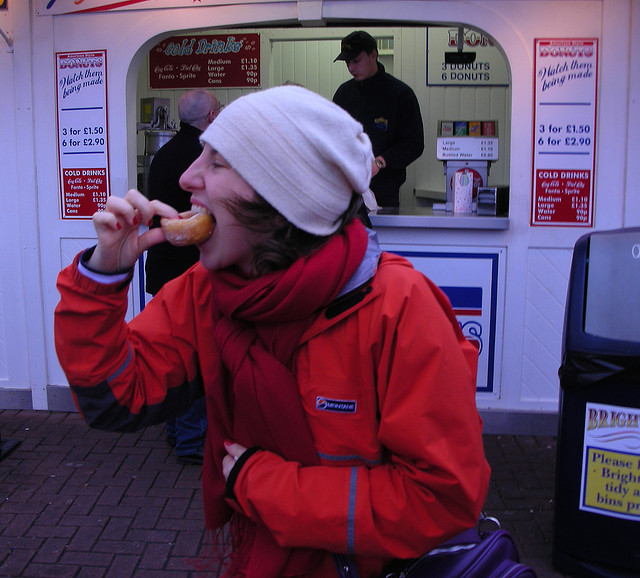<image>What brand is on the girls shirt? I don't know what brand is on the girl's shirt. It could be Pepsi, Northern, Walmart, Champion, Olympia, or Puma. What device is the woman holding? The woman might not be holding a device, it seems she is holding a donut or doughnut. What device is the woman holding? I am not sure. It can be seen that the woman is holding a donut or a doughnut. What brand is on the girls shirt? I am not sure what brand is on the girl's shirt. It can be seen 'pepsi', 'champion', 'walmart', 'puma', 'northern' or 'olympia'. 